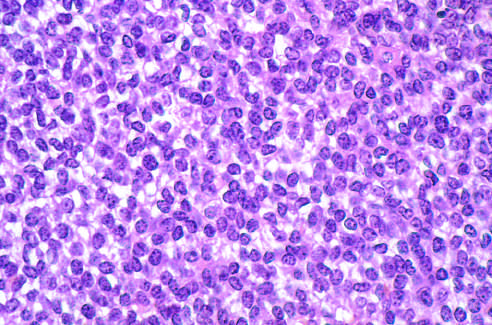what is ewing sarcoma composed of?
Answer the question using a single word or phrase. Sheets of small round cells with small amounts of clear cytoplasm 